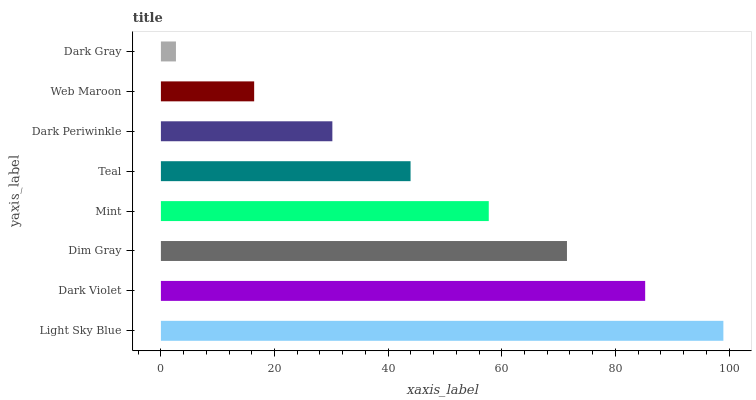Is Dark Gray the minimum?
Answer yes or no. Yes. Is Light Sky Blue the maximum?
Answer yes or no. Yes. Is Dark Violet the minimum?
Answer yes or no. No. Is Dark Violet the maximum?
Answer yes or no. No. Is Light Sky Blue greater than Dark Violet?
Answer yes or no. Yes. Is Dark Violet less than Light Sky Blue?
Answer yes or no. Yes. Is Dark Violet greater than Light Sky Blue?
Answer yes or no. No. Is Light Sky Blue less than Dark Violet?
Answer yes or no. No. Is Mint the high median?
Answer yes or no. Yes. Is Teal the low median?
Answer yes or no. Yes. Is Dark Violet the high median?
Answer yes or no. No. Is Dark Violet the low median?
Answer yes or no. No. 